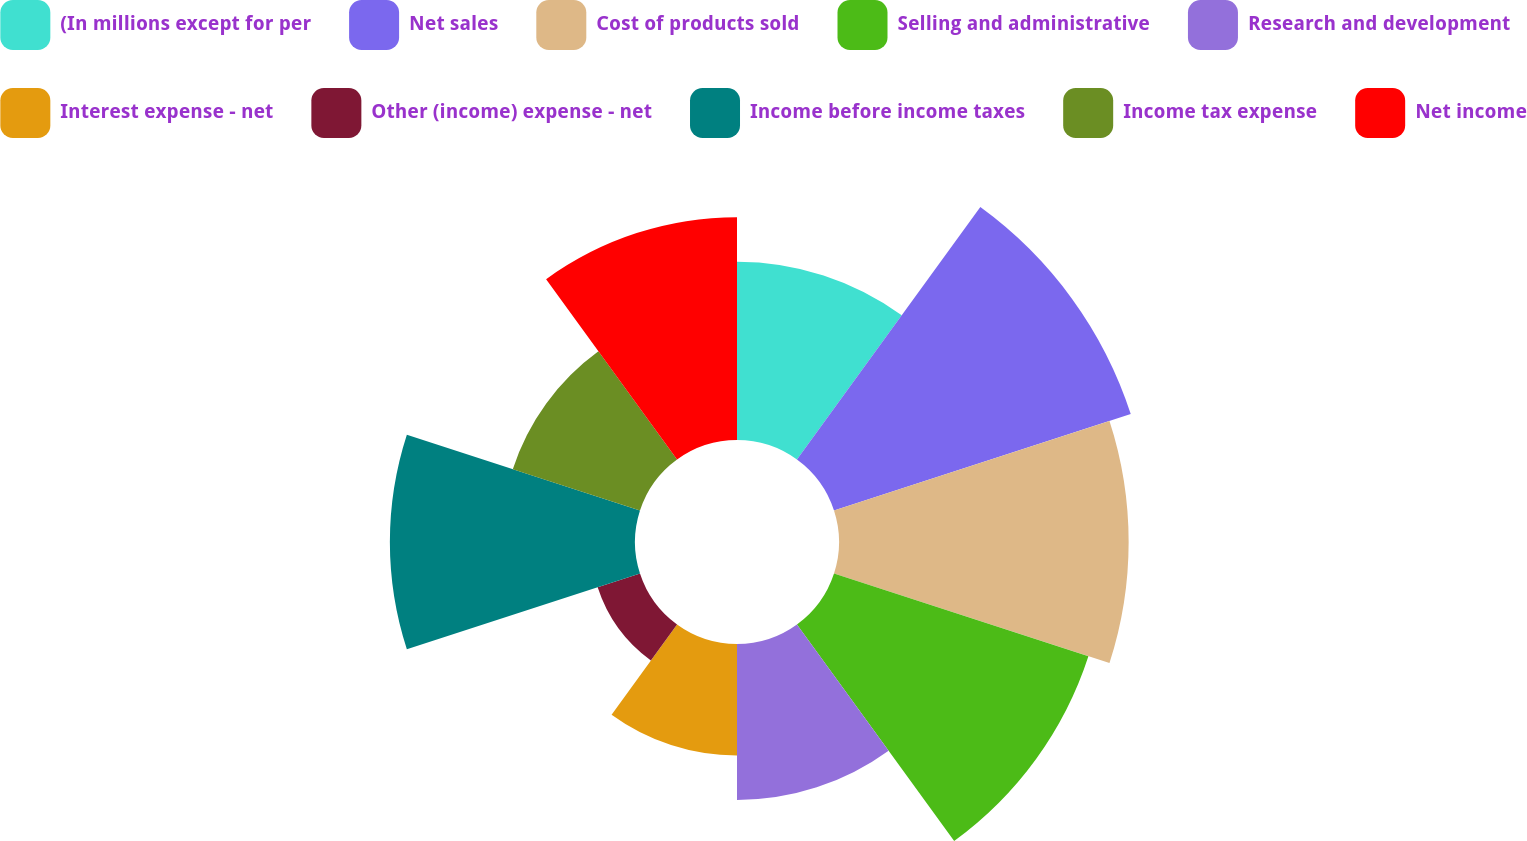<chart> <loc_0><loc_0><loc_500><loc_500><pie_chart><fcel>(In millions except for per<fcel>Net sales<fcel>Cost of products sold<fcel>Selling and administrative<fcel>Research and development<fcel>Interest expense - net<fcel>Other (income) expense - net<fcel>Income before income taxes<fcel>Income tax expense<fcel>Net income<nl><fcel>9.09%<fcel>15.91%<fcel>14.77%<fcel>13.64%<fcel>7.95%<fcel>5.68%<fcel>2.27%<fcel>12.5%<fcel>6.82%<fcel>11.36%<nl></chart> 